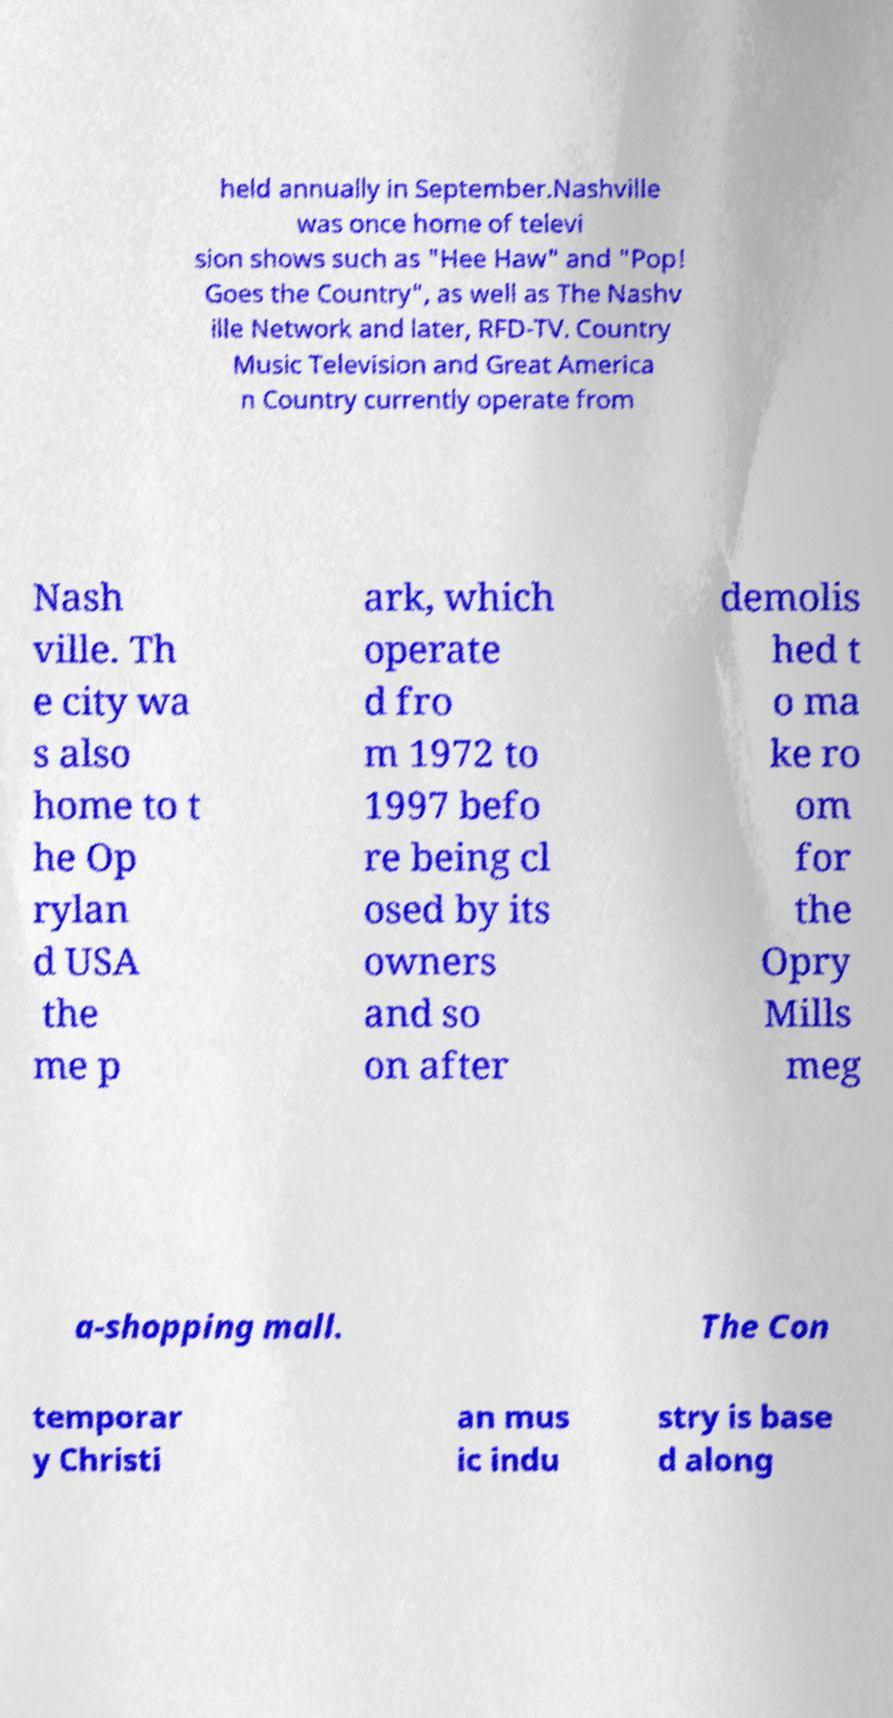Could you extract and type out the text from this image? held annually in September.Nashville was once home of televi sion shows such as "Hee Haw" and "Pop! Goes the Country", as well as The Nashv ille Network and later, RFD-TV. Country Music Television and Great America n Country currently operate from Nash ville. Th e city wa s also home to t he Op rylan d USA the me p ark, which operate d fro m 1972 to 1997 befo re being cl osed by its owners and so on after demolis hed t o ma ke ro om for the Opry Mills meg a-shopping mall. The Con temporar y Christi an mus ic indu stry is base d along 